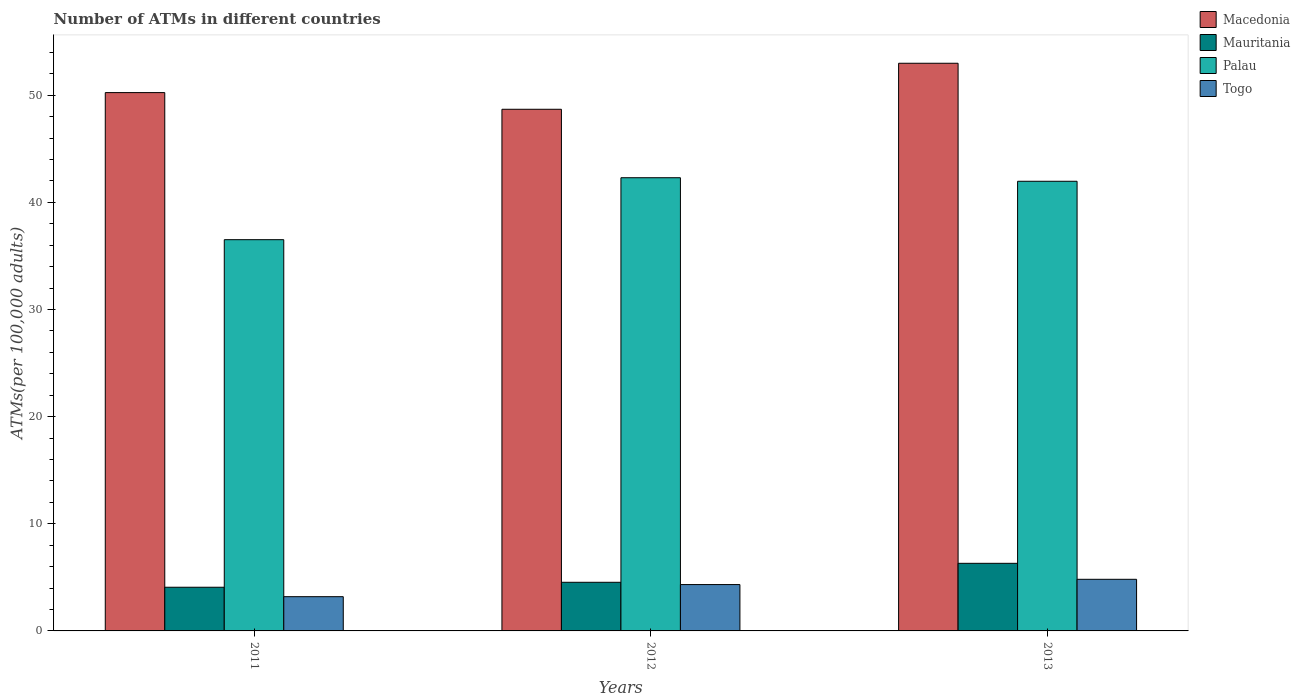How many bars are there on the 1st tick from the left?
Make the answer very short. 4. How many bars are there on the 1st tick from the right?
Offer a very short reply. 4. What is the label of the 2nd group of bars from the left?
Make the answer very short. 2012. In how many cases, is the number of bars for a given year not equal to the number of legend labels?
Give a very brief answer. 0. What is the number of ATMs in Palau in 2012?
Give a very brief answer. 42.3. Across all years, what is the maximum number of ATMs in Macedonia?
Your response must be concise. 52.98. Across all years, what is the minimum number of ATMs in Togo?
Offer a very short reply. 3.2. In which year was the number of ATMs in Macedonia maximum?
Ensure brevity in your answer.  2013. What is the total number of ATMs in Palau in the graph?
Make the answer very short. 120.78. What is the difference between the number of ATMs in Palau in 2012 and that in 2013?
Give a very brief answer. 0.33. What is the difference between the number of ATMs in Togo in 2011 and the number of ATMs in Mauritania in 2013?
Ensure brevity in your answer.  -3.11. What is the average number of ATMs in Togo per year?
Offer a terse response. 4.11. In the year 2012, what is the difference between the number of ATMs in Mauritania and number of ATMs in Macedonia?
Keep it short and to the point. -44.15. What is the ratio of the number of ATMs in Macedonia in 2012 to that in 2013?
Give a very brief answer. 0.92. Is the number of ATMs in Palau in 2012 less than that in 2013?
Keep it short and to the point. No. Is the difference between the number of ATMs in Mauritania in 2011 and 2013 greater than the difference between the number of ATMs in Macedonia in 2011 and 2013?
Offer a very short reply. Yes. What is the difference between the highest and the second highest number of ATMs in Togo?
Offer a very short reply. 0.49. What is the difference between the highest and the lowest number of ATMs in Togo?
Keep it short and to the point. 1.62. Is the sum of the number of ATMs in Mauritania in 2011 and 2012 greater than the maximum number of ATMs in Palau across all years?
Ensure brevity in your answer.  No. What does the 3rd bar from the left in 2012 represents?
Ensure brevity in your answer.  Palau. What does the 2nd bar from the right in 2011 represents?
Provide a succinct answer. Palau. How many bars are there?
Ensure brevity in your answer.  12. Are all the bars in the graph horizontal?
Make the answer very short. No. How many years are there in the graph?
Offer a very short reply. 3. What is the difference between two consecutive major ticks on the Y-axis?
Your response must be concise. 10. Are the values on the major ticks of Y-axis written in scientific E-notation?
Offer a very short reply. No. How many legend labels are there?
Give a very brief answer. 4. What is the title of the graph?
Your response must be concise. Number of ATMs in different countries. Does "Slovak Republic" appear as one of the legend labels in the graph?
Your answer should be very brief. No. What is the label or title of the Y-axis?
Your answer should be very brief. ATMs(per 100,0 adults). What is the ATMs(per 100,000 adults) of Macedonia in 2011?
Your answer should be very brief. 50.24. What is the ATMs(per 100,000 adults) of Mauritania in 2011?
Your answer should be compact. 4.08. What is the ATMs(per 100,000 adults) in Palau in 2011?
Offer a terse response. 36.52. What is the ATMs(per 100,000 adults) of Togo in 2011?
Ensure brevity in your answer.  3.2. What is the ATMs(per 100,000 adults) in Macedonia in 2012?
Keep it short and to the point. 48.69. What is the ATMs(per 100,000 adults) of Mauritania in 2012?
Your answer should be very brief. 4.54. What is the ATMs(per 100,000 adults) in Palau in 2012?
Your answer should be very brief. 42.3. What is the ATMs(per 100,000 adults) in Togo in 2012?
Give a very brief answer. 4.33. What is the ATMs(per 100,000 adults) in Macedonia in 2013?
Offer a very short reply. 52.98. What is the ATMs(per 100,000 adults) in Mauritania in 2013?
Your answer should be compact. 6.31. What is the ATMs(per 100,000 adults) in Palau in 2013?
Your answer should be compact. 41.97. What is the ATMs(per 100,000 adults) of Togo in 2013?
Provide a short and direct response. 4.82. Across all years, what is the maximum ATMs(per 100,000 adults) of Macedonia?
Give a very brief answer. 52.98. Across all years, what is the maximum ATMs(per 100,000 adults) of Mauritania?
Keep it short and to the point. 6.31. Across all years, what is the maximum ATMs(per 100,000 adults) in Palau?
Make the answer very short. 42.3. Across all years, what is the maximum ATMs(per 100,000 adults) of Togo?
Your answer should be very brief. 4.82. Across all years, what is the minimum ATMs(per 100,000 adults) in Macedonia?
Provide a short and direct response. 48.69. Across all years, what is the minimum ATMs(per 100,000 adults) in Mauritania?
Provide a succinct answer. 4.08. Across all years, what is the minimum ATMs(per 100,000 adults) of Palau?
Offer a very short reply. 36.52. Across all years, what is the minimum ATMs(per 100,000 adults) of Togo?
Give a very brief answer. 3.2. What is the total ATMs(per 100,000 adults) of Macedonia in the graph?
Your response must be concise. 151.91. What is the total ATMs(per 100,000 adults) in Mauritania in the graph?
Ensure brevity in your answer.  14.93. What is the total ATMs(per 100,000 adults) of Palau in the graph?
Offer a very short reply. 120.78. What is the total ATMs(per 100,000 adults) of Togo in the graph?
Your response must be concise. 12.34. What is the difference between the ATMs(per 100,000 adults) of Macedonia in 2011 and that in 2012?
Offer a terse response. 1.56. What is the difference between the ATMs(per 100,000 adults) of Mauritania in 2011 and that in 2012?
Ensure brevity in your answer.  -0.46. What is the difference between the ATMs(per 100,000 adults) in Palau in 2011 and that in 2012?
Your response must be concise. -5.78. What is the difference between the ATMs(per 100,000 adults) of Togo in 2011 and that in 2012?
Provide a succinct answer. -1.13. What is the difference between the ATMs(per 100,000 adults) of Macedonia in 2011 and that in 2013?
Offer a very short reply. -2.74. What is the difference between the ATMs(per 100,000 adults) of Mauritania in 2011 and that in 2013?
Make the answer very short. -2.23. What is the difference between the ATMs(per 100,000 adults) in Palau in 2011 and that in 2013?
Offer a terse response. -5.45. What is the difference between the ATMs(per 100,000 adults) in Togo in 2011 and that in 2013?
Make the answer very short. -1.62. What is the difference between the ATMs(per 100,000 adults) in Macedonia in 2012 and that in 2013?
Provide a short and direct response. -4.29. What is the difference between the ATMs(per 100,000 adults) of Mauritania in 2012 and that in 2013?
Give a very brief answer. -1.77. What is the difference between the ATMs(per 100,000 adults) in Palau in 2012 and that in 2013?
Your answer should be compact. 0.33. What is the difference between the ATMs(per 100,000 adults) of Togo in 2012 and that in 2013?
Your answer should be very brief. -0.49. What is the difference between the ATMs(per 100,000 adults) of Macedonia in 2011 and the ATMs(per 100,000 adults) of Mauritania in 2012?
Provide a short and direct response. 45.7. What is the difference between the ATMs(per 100,000 adults) of Macedonia in 2011 and the ATMs(per 100,000 adults) of Palau in 2012?
Offer a very short reply. 7.95. What is the difference between the ATMs(per 100,000 adults) of Macedonia in 2011 and the ATMs(per 100,000 adults) of Togo in 2012?
Make the answer very short. 45.92. What is the difference between the ATMs(per 100,000 adults) of Mauritania in 2011 and the ATMs(per 100,000 adults) of Palau in 2012?
Provide a short and direct response. -38.22. What is the difference between the ATMs(per 100,000 adults) in Mauritania in 2011 and the ATMs(per 100,000 adults) in Togo in 2012?
Make the answer very short. -0.25. What is the difference between the ATMs(per 100,000 adults) of Palau in 2011 and the ATMs(per 100,000 adults) of Togo in 2012?
Provide a short and direct response. 32.19. What is the difference between the ATMs(per 100,000 adults) of Macedonia in 2011 and the ATMs(per 100,000 adults) of Mauritania in 2013?
Make the answer very short. 43.93. What is the difference between the ATMs(per 100,000 adults) of Macedonia in 2011 and the ATMs(per 100,000 adults) of Palau in 2013?
Provide a short and direct response. 8.28. What is the difference between the ATMs(per 100,000 adults) of Macedonia in 2011 and the ATMs(per 100,000 adults) of Togo in 2013?
Provide a succinct answer. 45.43. What is the difference between the ATMs(per 100,000 adults) in Mauritania in 2011 and the ATMs(per 100,000 adults) in Palau in 2013?
Ensure brevity in your answer.  -37.89. What is the difference between the ATMs(per 100,000 adults) in Mauritania in 2011 and the ATMs(per 100,000 adults) in Togo in 2013?
Give a very brief answer. -0.74. What is the difference between the ATMs(per 100,000 adults) in Palau in 2011 and the ATMs(per 100,000 adults) in Togo in 2013?
Provide a short and direct response. 31.7. What is the difference between the ATMs(per 100,000 adults) in Macedonia in 2012 and the ATMs(per 100,000 adults) in Mauritania in 2013?
Make the answer very short. 42.38. What is the difference between the ATMs(per 100,000 adults) of Macedonia in 2012 and the ATMs(per 100,000 adults) of Palau in 2013?
Give a very brief answer. 6.72. What is the difference between the ATMs(per 100,000 adults) in Macedonia in 2012 and the ATMs(per 100,000 adults) in Togo in 2013?
Your response must be concise. 43.87. What is the difference between the ATMs(per 100,000 adults) in Mauritania in 2012 and the ATMs(per 100,000 adults) in Palau in 2013?
Make the answer very short. -37.43. What is the difference between the ATMs(per 100,000 adults) in Mauritania in 2012 and the ATMs(per 100,000 adults) in Togo in 2013?
Offer a very short reply. -0.28. What is the difference between the ATMs(per 100,000 adults) in Palau in 2012 and the ATMs(per 100,000 adults) in Togo in 2013?
Your response must be concise. 37.48. What is the average ATMs(per 100,000 adults) of Macedonia per year?
Keep it short and to the point. 50.64. What is the average ATMs(per 100,000 adults) in Mauritania per year?
Offer a very short reply. 4.97. What is the average ATMs(per 100,000 adults) of Palau per year?
Give a very brief answer. 40.26. What is the average ATMs(per 100,000 adults) of Togo per year?
Your answer should be compact. 4.11. In the year 2011, what is the difference between the ATMs(per 100,000 adults) in Macedonia and ATMs(per 100,000 adults) in Mauritania?
Provide a succinct answer. 46.17. In the year 2011, what is the difference between the ATMs(per 100,000 adults) of Macedonia and ATMs(per 100,000 adults) of Palau?
Offer a very short reply. 13.73. In the year 2011, what is the difference between the ATMs(per 100,000 adults) of Macedonia and ATMs(per 100,000 adults) of Togo?
Your response must be concise. 47.05. In the year 2011, what is the difference between the ATMs(per 100,000 adults) of Mauritania and ATMs(per 100,000 adults) of Palau?
Provide a succinct answer. -32.44. In the year 2011, what is the difference between the ATMs(per 100,000 adults) of Mauritania and ATMs(per 100,000 adults) of Togo?
Your response must be concise. 0.88. In the year 2011, what is the difference between the ATMs(per 100,000 adults) of Palau and ATMs(per 100,000 adults) of Togo?
Offer a very short reply. 33.32. In the year 2012, what is the difference between the ATMs(per 100,000 adults) of Macedonia and ATMs(per 100,000 adults) of Mauritania?
Provide a succinct answer. 44.15. In the year 2012, what is the difference between the ATMs(per 100,000 adults) in Macedonia and ATMs(per 100,000 adults) in Palau?
Your answer should be compact. 6.39. In the year 2012, what is the difference between the ATMs(per 100,000 adults) of Macedonia and ATMs(per 100,000 adults) of Togo?
Offer a very short reply. 44.36. In the year 2012, what is the difference between the ATMs(per 100,000 adults) in Mauritania and ATMs(per 100,000 adults) in Palau?
Your response must be concise. -37.76. In the year 2012, what is the difference between the ATMs(per 100,000 adults) of Mauritania and ATMs(per 100,000 adults) of Togo?
Your answer should be compact. 0.21. In the year 2012, what is the difference between the ATMs(per 100,000 adults) in Palau and ATMs(per 100,000 adults) in Togo?
Keep it short and to the point. 37.97. In the year 2013, what is the difference between the ATMs(per 100,000 adults) of Macedonia and ATMs(per 100,000 adults) of Mauritania?
Your response must be concise. 46.67. In the year 2013, what is the difference between the ATMs(per 100,000 adults) in Macedonia and ATMs(per 100,000 adults) in Palau?
Provide a short and direct response. 11.01. In the year 2013, what is the difference between the ATMs(per 100,000 adults) in Macedonia and ATMs(per 100,000 adults) in Togo?
Provide a short and direct response. 48.16. In the year 2013, what is the difference between the ATMs(per 100,000 adults) of Mauritania and ATMs(per 100,000 adults) of Palau?
Ensure brevity in your answer.  -35.66. In the year 2013, what is the difference between the ATMs(per 100,000 adults) in Mauritania and ATMs(per 100,000 adults) in Togo?
Provide a short and direct response. 1.49. In the year 2013, what is the difference between the ATMs(per 100,000 adults) in Palau and ATMs(per 100,000 adults) in Togo?
Offer a terse response. 37.15. What is the ratio of the ATMs(per 100,000 adults) of Macedonia in 2011 to that in 2012?
Give a very brief answer. 1.03. What is the ratio of the ATMs(per 100,000 adults) of Mauritania in 2011 to that in 2012?
Your answer should be compact. 0.9. What is the ratio of the ATMs(per 100,000 adults) in Palau in 2011 to that in 2012?
Your answer should be very brief. 0.86. What is the ratio of the ATMs(per 100,000 adults) of Togo in 2011 to that in 2012?
Offer a terse response. 0.74. What is the ratio of the ATMs(per 100,000 adults) of Macedonia in 2011 to that in 2013?
Make the answer very short. 0.95. What is the ratio of the ATMs(per 100,000 adults) of Mauritania in 2011 to that in 2013?
Offer a terse response. 0.65. What is the ratio of the ATMs(per 100,000 adults) in Palau in 2011 to that in 2013?
Provide a succinct answer. 0.87. What is the ratio of the ATMs(per 100,000 adults) in Togo in 2011 to that in 2013?
Provide a succinct answer. 0.66. What is the ratio of the ATMs(per 100,000 adults) in Macedonia in 2012 to that in 2013?
Give a very brief answer. 0.92. What is the ratio of the ATMs(per 100,000 adults) in Mauritania in 2012 to that in 2013?
Ensure brevity in your answer.  0.72. What is the ratio of the ATMs(per 100,000 adults) of Palau in 2012 to that in 2013?
Make the answer very short. 1.01. What is the ratio of the ATMs(per 100,000 adults) in Togo in 2012 to that in 2013?
Your response must be concise. 0.9. What is the difference between the highest and the second highest ATMs(per 100,000 adults) in Macedonia?
Give a very brief answer. 2.74. What is the difference between the highest and the second highest ATMs(per 100,000 adults) of Mauritania?
Make the answer very short. 1.77. What is the difference between the highest and the second highest ATMs(per 100,000 adults) in Palau?
Ensure brevity in your answer.  0.33. What is the difference between the highest and the second highest ATMs(per 100,000 adults) of Togo?
Keep it short and to the point. 0.49. What is the difference between the highest and the lowest ATMs(per 100,000 adults) of Macedonia?
Provide a succinct answer. 4.29. What is the difference between the highest and the lowest ATMs(per 100,000 adults) of Mauritania?
Offer a terse response. 2.23. What is the difference between the highest and the lowest ATMs(per 100,000 adults) of Palau?
Provide a short and direct response. 5.78. What is the difference between the highest and the lowest ATMs(per 100,000 adults) of Togo?
Your answer should be very brief. 1.62. 